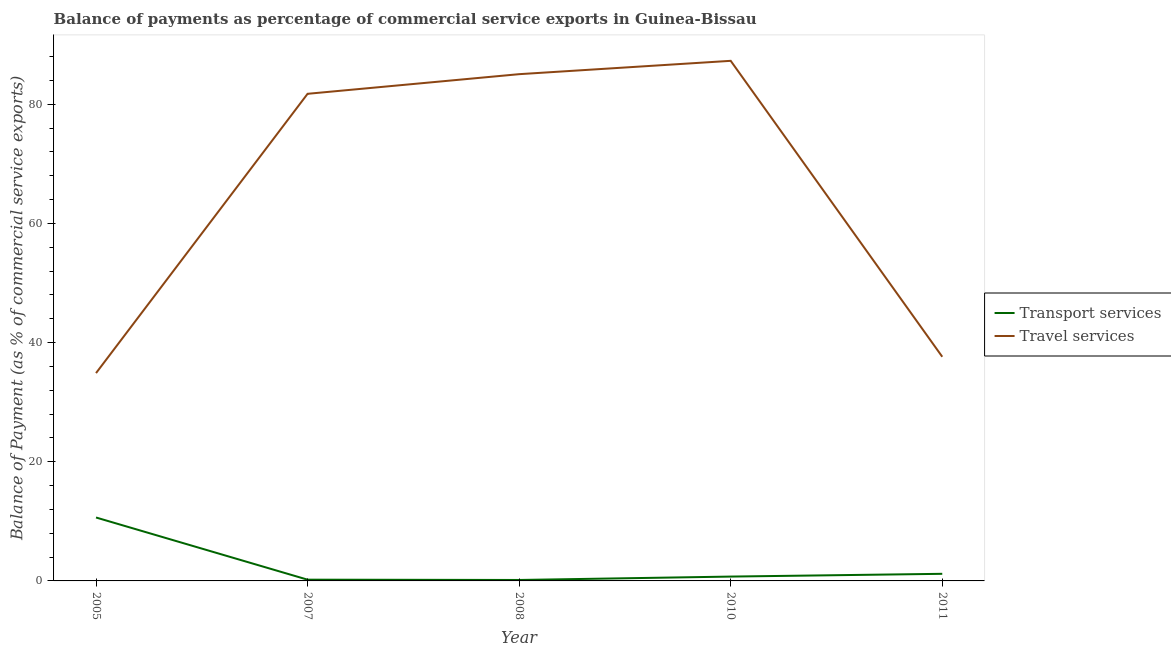How many different coloured lines are there?
Your answer should be very brief. 2. Does the line corresponding to balance of payments of travel services intersect with the line corresponding to balance of payments of transport services?
Offer a very short reply. No. Is the number of lines equal to the number of legend labels?
Your answer should be compact. Yes. What is the balance of payments of travel services in 2007?
Your response must be concise. 81.74. Across all years, what is the maximum balance of payments of travel services?
Make the answer very short. 87.27. Across all years, what is the minimum balance of payments of transport services?
Ensure brevity in your answer.  0.16. In which year was the balance of payments of transport services minimum?
Provide a short and direct response. 2008. What is the total balance of payments of travel services in the graph?
Keep it short and to the point. 326.54. What is the difference between the balance of payments of transport services in 2005 and that in 2011?
Offer a terse response. 9.45. What is the difference between the balance of payments of travel services in 2007 and the balance of payments of transport services in 2010?
Make the answer very short. 81.01. What is the average balance of payments of travel services per year?
Offer a very short reply. 65.31. In the year 2011, what is the difference between the balance of payments of transport services and balance of payments of travel services?
Keep it short and to the point. -36.42. What is the ratio of the balance of payments of transport services in 2005 to that in 2008?
Offer a terse response. 66.55. Is the balance of payments of travel services in 2008 less than that in 2010?
Give a very brief answer. Yes. Is the difference between the balance of payments of travel services in 2005 and 2011 greater than the difference between the balance of payments of transport services in 2005 and 2011?
Give a very brief answer. No. What is the difference between the highest and the second highest balance of payments of travel services?
Ensure brevity in your answer.  2.24. What is the difference between the highest and the lowest balance of payments of travel services?
Provide a succinct answer. 52.4. In how many years, is the balance of payments of travel services greater than the average balance of payments of travel services taken over all years?
Offer a very short reply. 3. Does the balance of payments of travel services monotonically increase over the years?
Your response must be concise. No. Is the balance of payments of transport services strictly greater than the balance of payments of travel services over the years?
Provide a short and direct response. No. What is the difference between two consecutive major ticks on the Y-axis?
Your answer should be compact. 20. Does the graph contain grids?
Your answer should be compact. No. How many legend labels are there?
Make the answer very short. 2. How are the legend labels stacked?
Give a very brief answer. Vertical. What is the title of the graph?
Offer a terse response. Balance of payments as percentage of commercial service exports in Guinea-Bissau. Does "Quasi money growth" appear as one of the legend labels in the graph?
Give a very brief answer. No. What is the label or title of the Y-axis?
Your response must be concise. Balance of Payment (as % of commercial service exports). What is the Balance of Payment (as % of commercial service exports) in Transport services in 2005?
Provide a succinct answer. 10.64. What is the Balance of Payment (as % of commercial service exports) in Travel services in 2005?
Offer a terse response. 34.88. What is the Balance of Payment (as % of commercial service exports) in Transport services in 2007?
Keep it short and to the point. 0.21. What is the Balance of Payment (as % of commercial service exports) in Travel services in 2007?
Your response must be concise. 81.74. What is the Balance of Payment (as % of commercial service exports) in Transport services in 2008?
Your answer should be very brief. 0.16. What is the Balance of Payment (as % of commercial service exports) of Travel services in 2008?
Make the answer very short. 85.04. What is the Balance of Payment (as % of commercial service exports) of Transport services in 2010?
Your answer should be compact. 0.73. What is the Balance of Payment (as % of commercial service exports) of Travel services in 2010?
Make the answer very short. 87.27. What is the Balance of Payment (as % of commercial service exports) in Transport services in 2011?
Offer a very short reply. 1.19. What is the Balance of Payment (as % of commercial service exports) in Travel services in 2011?
Ensure brevity in your answer.  37.61. Across all years, what is the maximum Balance of Payment (as % of commercial service exports) of Transport services?
Provide a succinct answer. 10.64. Across all years, what is the maximum Balance of Payment (as % of commercial service exports) of Travel services?
Give a very brief answer. 87.27. Across all years, what is the minimum Balance of Payment (as % of commercial service exports) in Transport services?
Your answer should be compact. 0.16. Across all years, what is the minimum Balance of Payment (as % of commercial service exports) of Travel services?
Offer a terse response. 34.88. What is the total Balance of Payment (as % of commercial service exports) of Transport services in the graph?
Offer a terse response. 12.94. What is the total Balance of Payment (as % of commercial service exports) in Travel services in the graph?
Provide a succinct answer. 326.54. What is the difference between the Balance of Payment (as % of commercial service exports) in Transport services in 2005 and that in 2007?
Keep it short and to the point. 10.43. What is the difference between the Balance of Payment (as % of commercial service exports) in Travel services in 2005 and that in 2007?
Ensure brevity in your answer.  -46.87. What is the difference between the Balance of Payment (as % of commercial service exports) of Transport services in 2005 and that in 2008?
Your answer should be compact. 10.48. What is the difference between the Balance of Payment (as % of commercial service exports) of Travel services in 2005 and that in 2008?
Your answer should be very brief. -50.16. What is the difference between the Balance of Payment (as % of commercial service exports) in Transport services in 2005 and that in 2010?
Keep it short and to the point. 9.91. What is the difference between the Balance of Payment (as % of commercial service exports) in Travel services in 2005 and that in 2010?
Make the answer very short. -52.4. What is the difference between the Balance of Payment (as % of commercial service exports) of Transport services in 2005 and that in 2011?
Your answer should be very brief. 9.45. What is the difference between the Balance of Payment (as % of commercial service exports) of Travel services in 2005 and that in 2011?
Offer a very short reply. -2.74. What is the difference between the Balance of Payment (as % of commercial service exports) in Transport services in 2007 and that in 2008?
Provide a succinct answer. 0.05. What is the difference between the Balance of Payment (as % of commercial service exports) in Travel services in 2007 and that in 2008?
Keep it short and to the point. -3.29. What is the difference between the Balance of Payment (as % of commercial service exports) in Transport services in 2007 and that in 2010?
Offer a very short reply. -0.52. What is the difference between the Balance of Payment (as % of commercial service exports) in Travel services in 2007 and that in 2010?
Your answer should be very brief. -5.53. What is the difference between the Balance of Payment (as % of commercial service exports) of Transport services in 2007 and that in 2011?
Your answer should be very brief. -0.98. What is the difference between the Balance of Payment (as % of commercial service exports) in Travel services in 2007 and that in 2011?
Your response must be concise. 44.13. What is the difference between the Balance of Payment (as % of commercial service exports) of Transport services in 2008 and that in 2010?
Provide a succinct answer. -0.57. What is the difference between the Balance of Payment (as % of commercial service exports) in Travel services in 2008 and that in 2010?
Keep it short and to the point. -2.24. What is the difference between the Balance of Payment (as % of commercial service exports) in Transport services in 2008 and that in 2011?
Offer a very short reply. -1.03. What is the difference between the Balance of Payment (as % of commercial service exports) in Travel services in 2008 and that in 2011?
Ensure brevity in your answer.  47.42. What is the difference between the Balance of Payment (as % of commercial service exports) in Transport services in 2010 and that in 2011?
Keep it short and to the point. -0.46. What is the difference between the Balance of Payment (as % of commercial service exports) of Travel services in 2010 and that in 2011?
Keep it short and to the point. 49.66. What is the difference between the Balance of Payment (as % of commercial service exports) of Transport services in 2005 and the Balance of Payment (as % of commercial service exports) of Travel services in 2007?
Offer a very short reply. -71.1. What is the difference between the Balance of Payment (as % of commercial service exports) of Transport services in 2005 and the Balance of Payment (as % of commercial service exports) of Travel services in 2008?
Your answer should be very brief. -74.39. What is the difference between the Balance of Payment (as % of commercial service exports) in Transport services in 2005 and the Balance of Payment (as % of commercial service exports) in Travel services in 2010?
Provide a succinct answer. -76.63. What is the difference between the Balance of Payment (as % of commercial service exports) in Transport services in 2005 and the Balance of Payment (as % of commercial service exports) in Travel services in 2011?
Offer a terse response. -26.97. What is the difference between the Balance of Payment (as % of commercial service exports) of Transport services in 2007 and the Balance of Payment (as % of commercial service exports) of Travel services in 2008?
Offer a very short reply. -84.83. What is the difference between the Balance of Payment (as % of commercial service exports) in Transport services in 2007 and the Balance of Payment (as % of commercial service exports) in Travel services in 2010?
Keep it short and to the point. -87.06. What is the difference between the Balance of Payment (as % of commercial service exports) in Transport services in 2007 and the Balance of Payment (as % of commercial service exports) in Travel services in 2011?
Give a very brief answer. -37.4. What is the difference between the Balance of Payment (as % of commercial service exports) in Transport services in 2008 and the Balance of Payment (as % of commercial service exports) in Travel services in 2010?
Keep it short and to the point. -87.11. What is the difference between the Balance of Payment (as % of commercial service exports) of Transport services in 2008 and the Balance of Payment (as % of commercial service exports) of Travel services in 2011?
Your answer should be compact. -37.45. What is the difference between the Balance of Payment (as % of commercial service exports) of Transport services in 2010 and the Balance of Payment (as % of commercial service exports) of Travel services in 2011?
Make the answer very short. -36.88. What is the average Balance of Payment (as % of commercial service exports) in Transport services per year?
Provide a succinct answer. 2.59. What is the average Balance of Payment (as % of commercial service exports) of Travel services per year?
Your answer should be compact. 65.31. In the year 2005, what is the difference between the Balance of Payment (as % of commercial service exports) of Transport services and Balance of Payment (as % of commercial service exports) of Travel services?
Your response must be concise. -24.23. In the year 2007, what is the difference between the Balance of Payment (as % of commercial service exports) in Transport services and Balance of Payment (as % of commercial service exports) in Travel services?
Keep it short and to the point. -81.53. In the year 2008, what is the difference between the Balance of Payment (as % of commercial service exports) of Transport services and Balance of Payment (as % of commercial service exports) of Travel services?
Offer a terse response. -84.88. In the year 2010, what is the difference between the Balance of Payment (as % of commercial service exports) of Transport services and Balance of Payment (as % of commercial service exports) of Travel services?
Make the answer very short. -86.54. In the year 2011, what is the difference between the Balance of Payment (as % of commercial service exports) of Transport services and Balance of Payment (as % of commercial service exports) of Travel services?
Offer a terse response. -36.42. What is the ratio of the Balance of Payment (as % of commercial service exports) of Transport services in 2005 to that in 2007?
Offer a very short reply. 50.76. What is the ratio of the Balance of Payment (as % of commercial service exports) of Travel services in 2005 to that in 2007?
Your response must be concise. 0.43. What is the ratio of the Balance of Payment (as % of commercial service exports) in Transport services in 2005 to that in 2008?
Offer a terse response. 66.55. What is the ratio of the Balance of Payment (as % of commercial service exports) of Travel services in 2005 to that in 2008?
Your response must be concise. 0.41. What is the ratio of the Balance of Payment (as % of commercial service exports) in Transport services in 2005 to that in 2010?
Offer a terse response. 14.58. What is the ratio of the Balance of Payment (as % of commercial service exports) in Travel services in 2005 to that in 2010?
Give a very brief answer. 0.4. What is the ratio of the Balance of Payment (as % of commercial service exports) of Transport services in 2005 to that in 2011?
Keep it short and to the point. 8.91. What is the ratio of the Balance of Payment (as % of commercial service exports) of Travel services in 2005 to that in 2011?
Make the answer very short. 0.93. What is the ratio of the Balance of Payment (as % of commercial service exports) of Transport services in 2007 to that in 2008?
Your answer should be very brief. 1.31. What is the ratio of the Balance of Payment (as % of commercial service exports) in Travel services in 2007 to that in 2008?
Offer a very short reply. 0.96. What is the ratio of the Balance of Payment (as % of commercial service exports) in Transport services in 2007 to that in 2010?
Your answer should be very brief. 0.29. What is the ratio of the Balance of Payment (as % of commercial service exports) of Travel services in 2007 to that in 2010?
Keep it short and to the point. 0.94. What is the ratio of the Balance of Payment (as % of commercial service exports) of Transport services in 2007 to that in 2011?
Offer a terse response. 0.18. What is the ratio of the Balance of Payment (as % of commercial service exports) of Travel services in 2007 to that in 2011?
Your response must be concise. 2.17. What is the ratio of the Balance of Payment (as % of commercial service exports) in Transport services in 2008 to that in 2010?
Provide a short and direct response. 0.22. What is the ratio of the Balance of Payment (as % of commercial service exports) of Travel services in 2008 to that in 2010?
Offer a terse response. 0.97. What is the ratio of the Balance of Payment (as % of commercial service exports) of Transport services in 2008 to that in 2011?
Your answer should be very brief. 0.13. What is the ratio of the Balance of Payment (as % of commercial service exports) of Travel services in 2008 to that in 2011?
Provide a short and direct response. 2.26. What is the ratio of the Balance of Payment (as % of commercial service exports) in Transport services in 2010 to that in 2011?
Your answer should be very brief. 0.61. What is the ratio of the Balance of Payment (as % of commercial service exports) in Travel services in 2010 to that in 2011?
Keep it short and to the point. 2.32. What is the difference between the highest and the second highest Balance of Payment (as % of commercial service exports) of Transport services?
Make the answer very short. 9.45. What is the difference between the highest and the second highest Balance of Payment (as % of commercial service exports) of Travel services?
Provide a succinct answer. 2.24. What is the difference between the highest and the lowest Balance of Payment (as % of commercial service exports) in Transport services?
Offer a terse response. 10.48. What is the difference between the highest and the lowest Balance of Payment (as % of commercial service exports) in Travel services?
Offer a terse response. 52.4. 